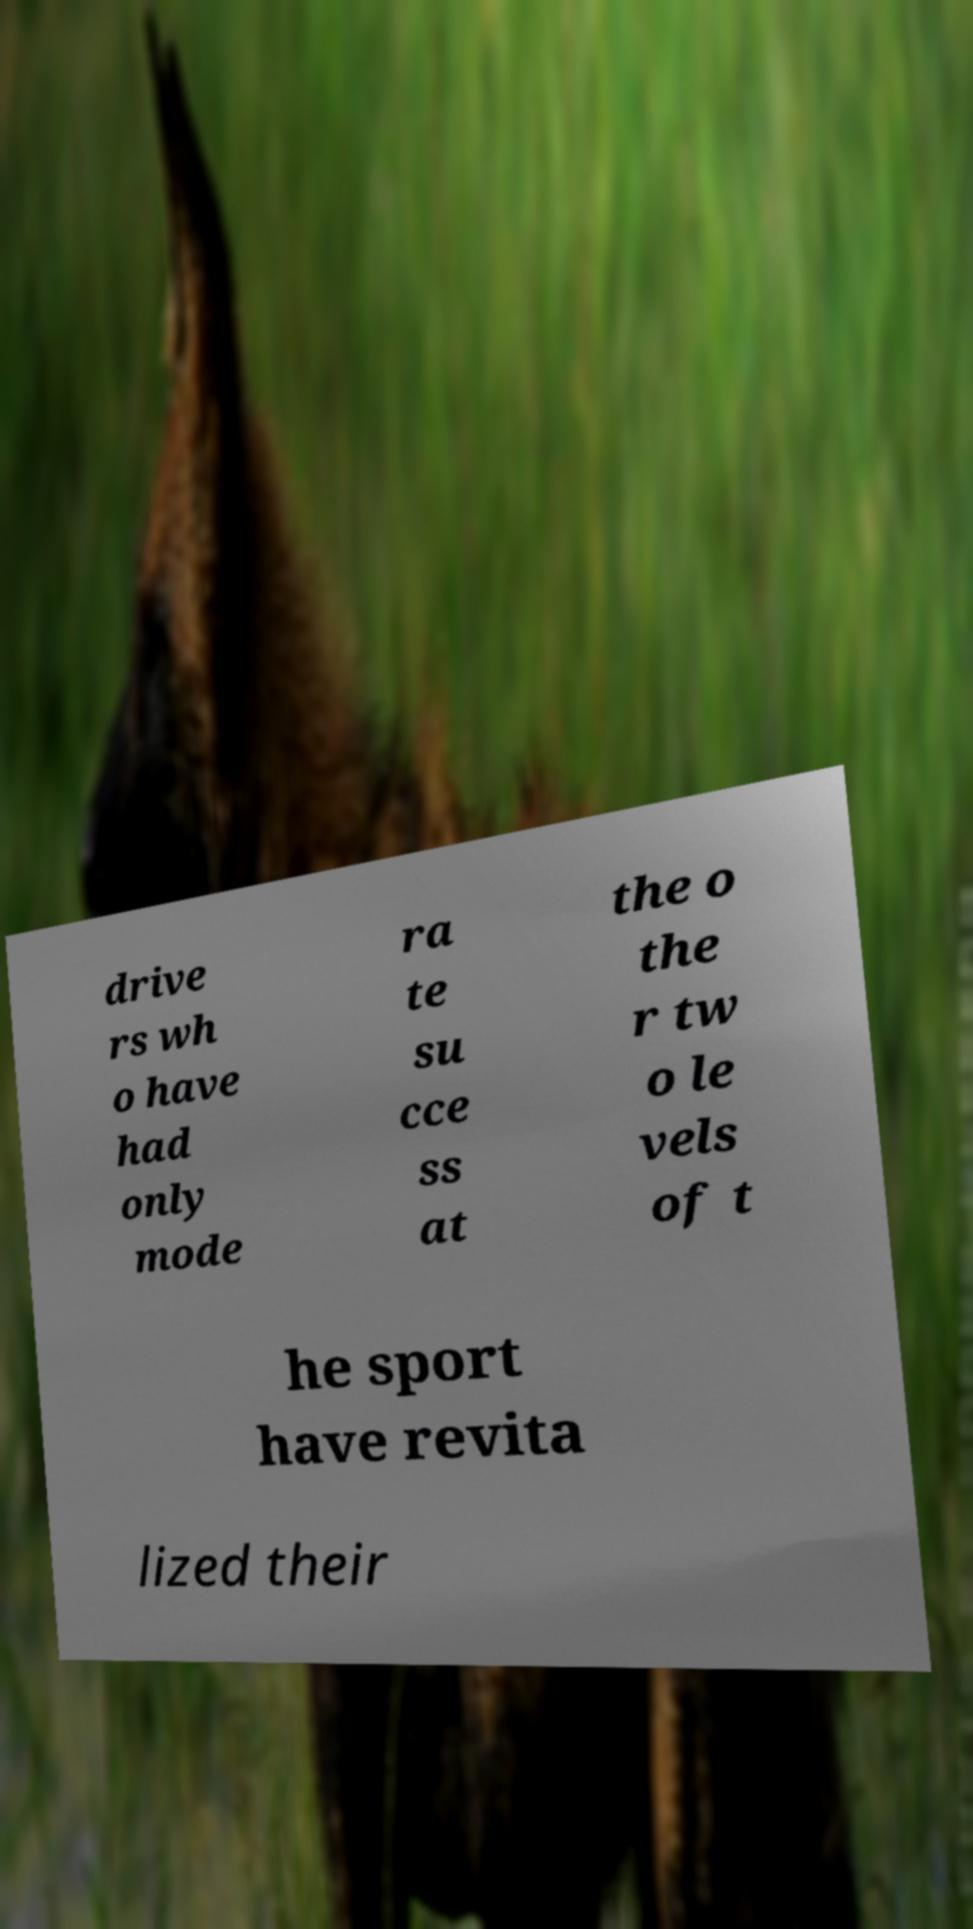Could you extract and type out the text from this image? drive rs wh o have had only mode ra te su cce ss at the o the r tw o le vels of t he sport have revita lized their 